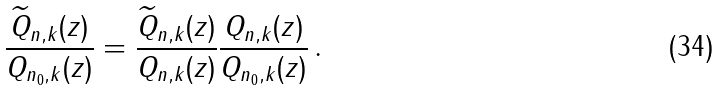<formula> <loc_0><loc_0><loc_500><loc_500>\frac { \widetilde { Q } _ { n , k } ( z ) } { Q _ { n _ { 0 } , k } ( z ) } = \frac { \widetilde { Q } _ { n , k } ( z ) } { Q _ { n , k } ( z ) } \frac { Q _ { n , k } ( z ) } { Q _ { n _ { 0 } , k } ( z ) } \, .</formula> 